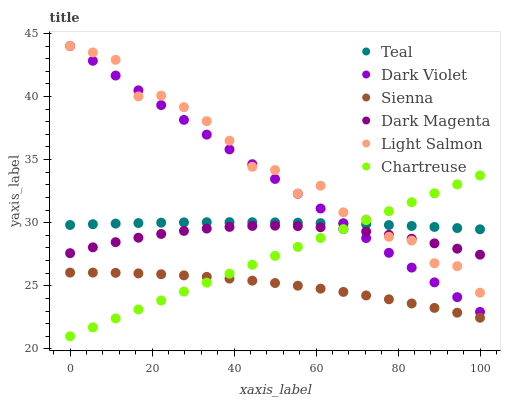Does Sienna have the minimum area under the curve?
Answer yes or no. Yes. Does Light Salmon have the maximum area under the curve?
Answer yes or no. Yes. Does Dark Magenta have the minimum area under the curve?
Answer yes or no. No. Does Dark Magenta have the maximum area under the curve?
Answer yes or no. No. Is Dark Violet the smoothest?
Answer yes or no. Yes. Is Light Salmon the roughest?
Answer yes or no. Yes. Is Dark Magenta the smoothest?
Answer yes or no. No. Is Dark Magenta the roughest?
Answer yes or no. No. Does Chartreuse have the lowest value?
Answer yes or no. Yes. Does Dark Magenta have the lowest value?
Answer yes or no. No. Does Dark Violet have the highest value?
Answer yes or no. Yes. Does Dark Magenta have the highest value?
Answer yes or no. No. Is Sienna less than Dark Magenta?
Answer yes or no. Yes. Is Teal greater than Sienna?
Answer yes or no. Yes. Does Light Salmon intersect Dark Magenta?
Answer yes or no. Yes. Is Light Salmon less than Dark Magenta?
Answer yes or no. No. Is Light Salmon greater than Dark Magenta?
Answer yes or no. No. Does Sienna intersect Dark Magenta?
Answer yes or no. No. 